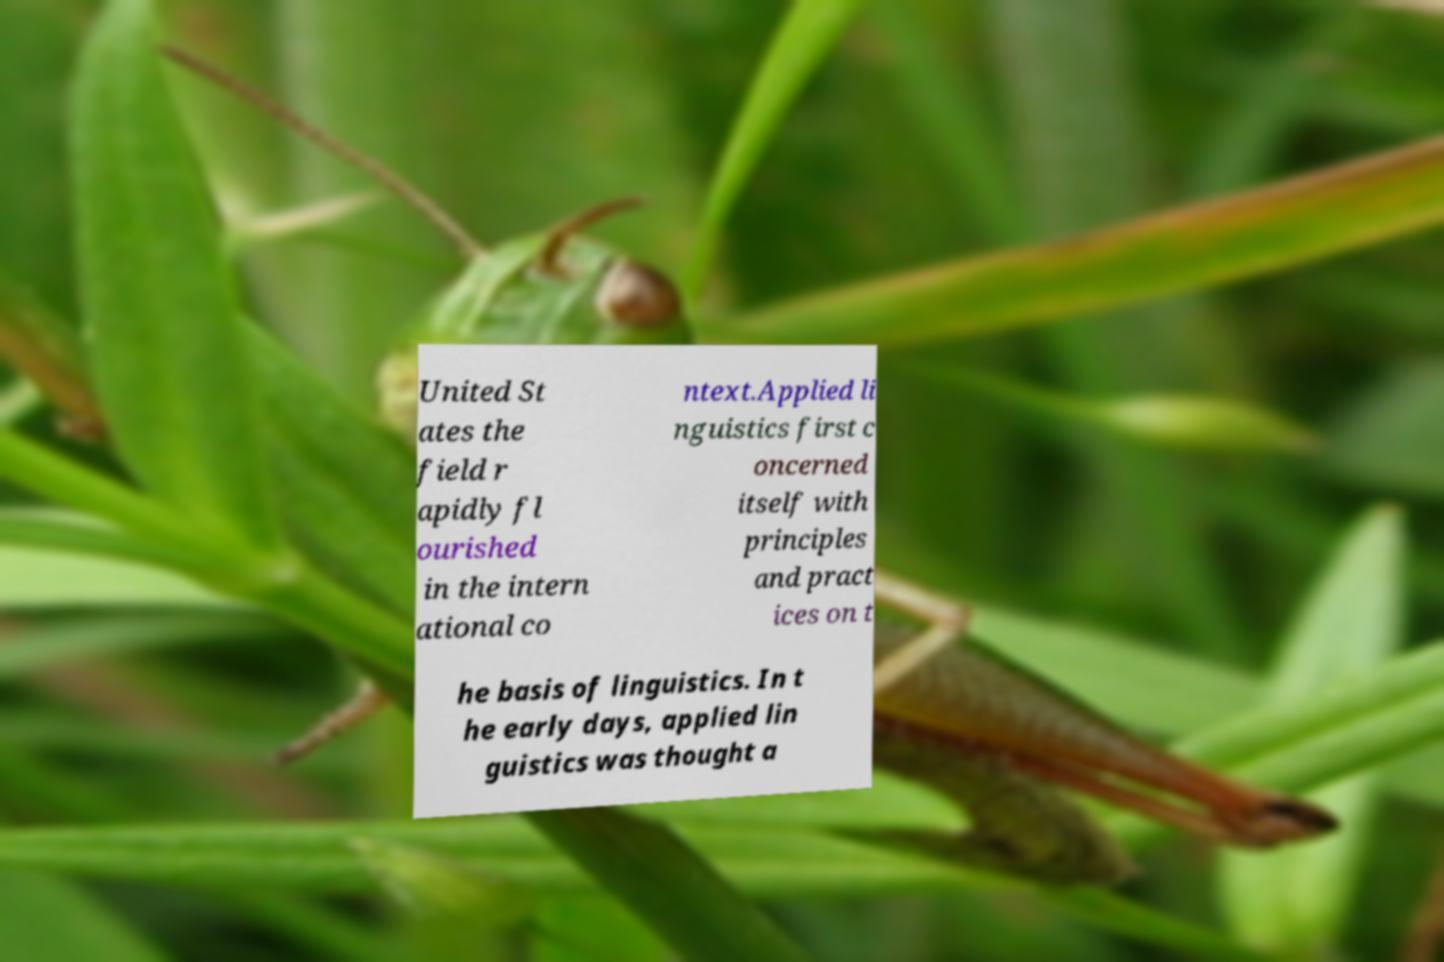Could you extract and type out the text from this image? United St ates the field r apidly fl ourished in the intern ational co ntext.Applied li nguistics first c oncerned itself with principles and pract ices on t he basis of linguistics. In t he early days, applied lin guistics was thought a 